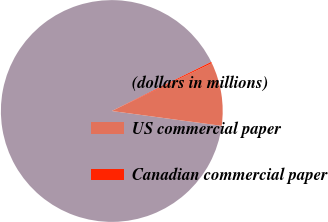<chart> <loc_0><loc_0><loc_500><loc_500><pie_chart><fcel>(dollars in millions)<fcel>US commercial paper<fcel>Canadian commercial paper<nl><fcel>90.57%<fcel>9.24%<fcel>0.2%<nl></chart> 